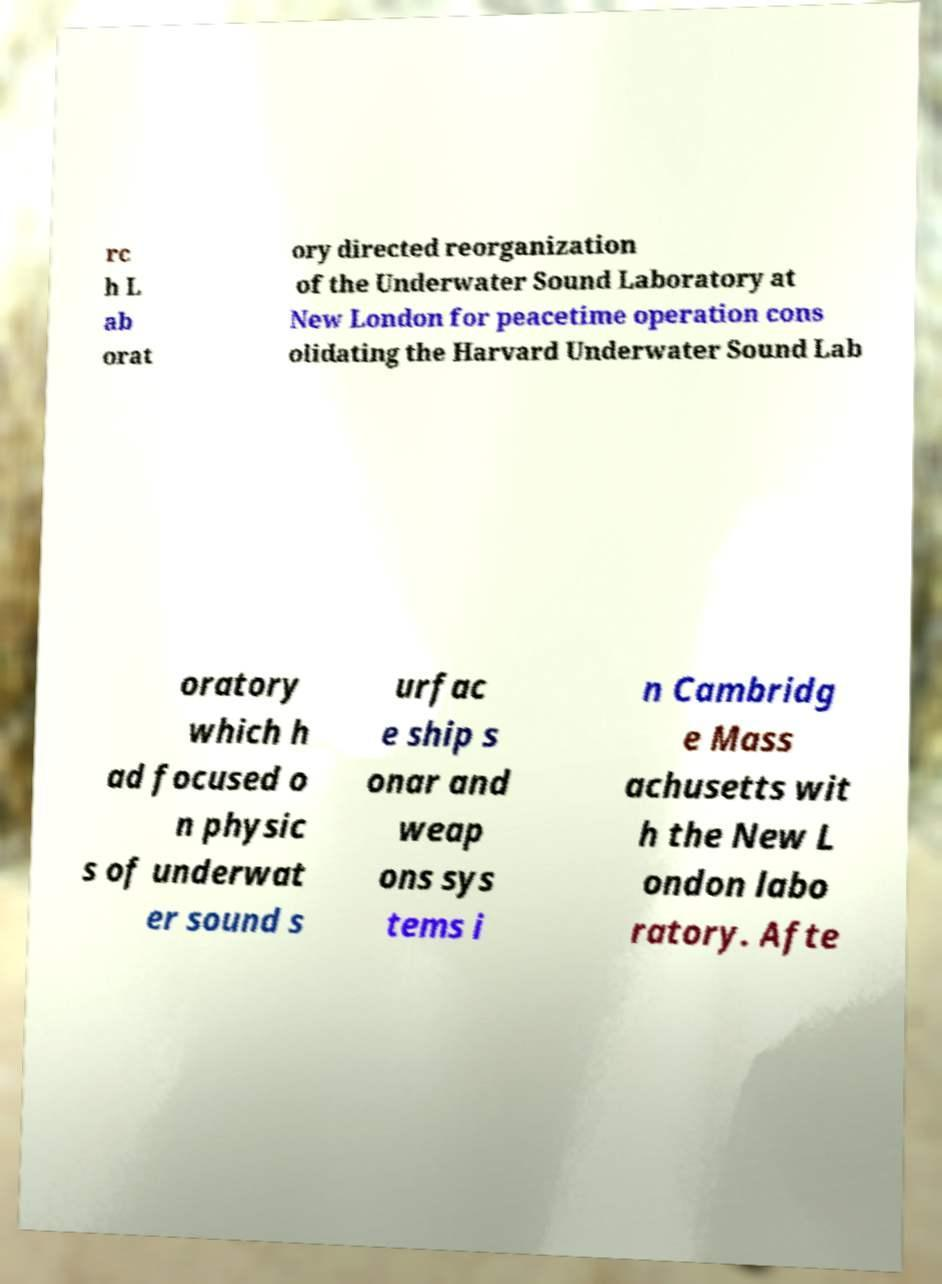What messages or text are displayed in this image? I need them in a readable, typed format. rc h L ab orat ory directed reorganization of the Underwater Sound Laboratory at New London for peacetime operation cons olidating the Harvard Underwater Sound Lab oratory which h ad focused o n physic s of underwat er sound s urfac e ship s onar and weap ons sys tems i n Cambridg e Mass achusetts wit h the New L ondon labo ratory. Afte 